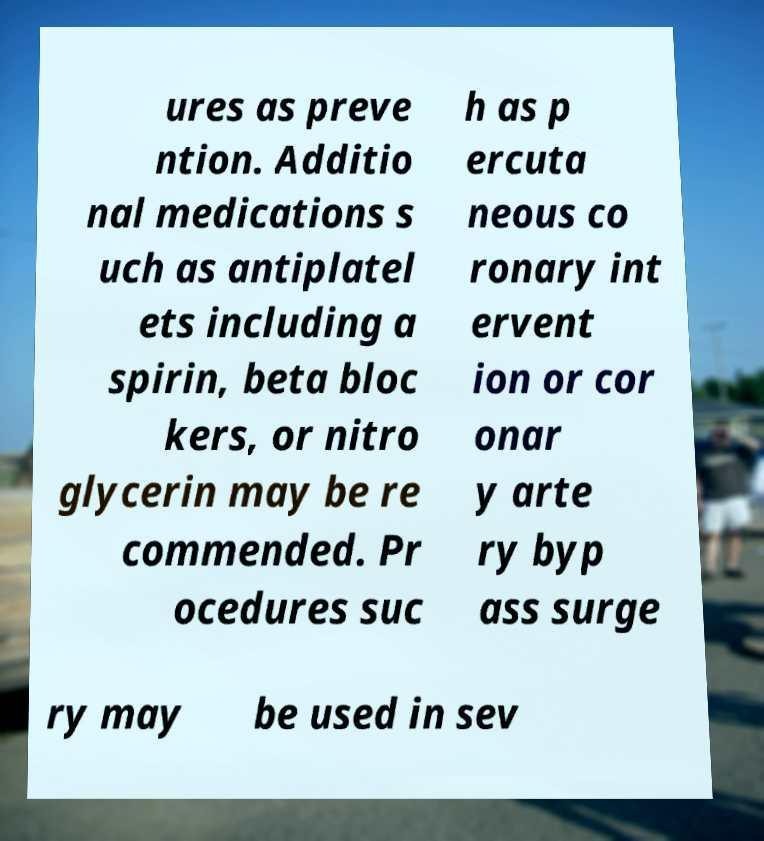I need the written content from this picture converted into text. Can you do that? ures as preve ntion. Additio nal medications s uch as antiplatel ets including a spirin, beta bloc kers, or nitro glycerin may be re commended. Pr ocedures suc h as p ercuta neous co ronary int ervent ion or cor onar y arte ry byp ass surge ry may be used in sev 